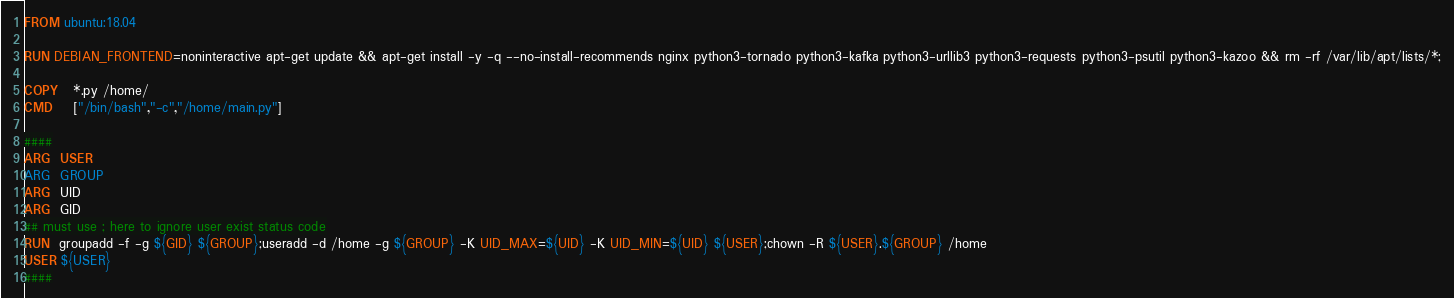Convert code to text. <code><loc_0><loc_0><loc_500><loc_500><_Dockerfile_>
FROM ubuntu:18.04

RUN DEBIAN_FRONTEND=noninteractive apt-get update && apt-get install -y -q --no-install-recommends nginx python3-tornado python3-kafka python3-urllib3 python3-requests python3-psutil python3-kazoo && rm -rf /var/lib/apt/lists/*;

COPY   *.py /home/
CMD    ["/bin/bash","-c","/home/main.py"]

####
ARG  USER
ARG  GROUP
ARG  UID
ARG  GID
## must use ; here to ignore user exist status code
RUN  groupadd -f -g ${GID} ${GROUP};useradd -d /home -g ${GROUP} -K UID_MAX=${UID} -K UID_MIN=${UID} ${USER};chown -R ${USER}.${GROUP} /home
USER ${USER}
####

</code> 